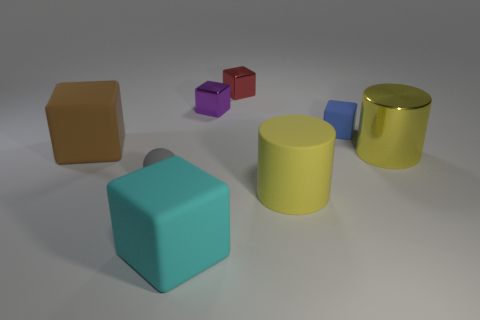Subtract 3 cubes. How many cubes are left? 2 Subtract all large cyan matte blocks. How many blocks are left? 4 Subtract all red cubes. How many cubes are left? 4 Add 1 large yellow things. How many objects exist? 9 Subtract all blue blocks. Subtract all gray balls. How many blocks are left? 4 Subtract all blocks. How many objects are left? 3 Add 8 red things. How many red things are left? 9 Add 5 cubes. How many cubes exist? 10 Subtract 0 blue cylinders. How many objects are left? 8 Subtract all cyan rubber blocks. Subtract all large yellow rubber cylinders. How many objects are left? 6 